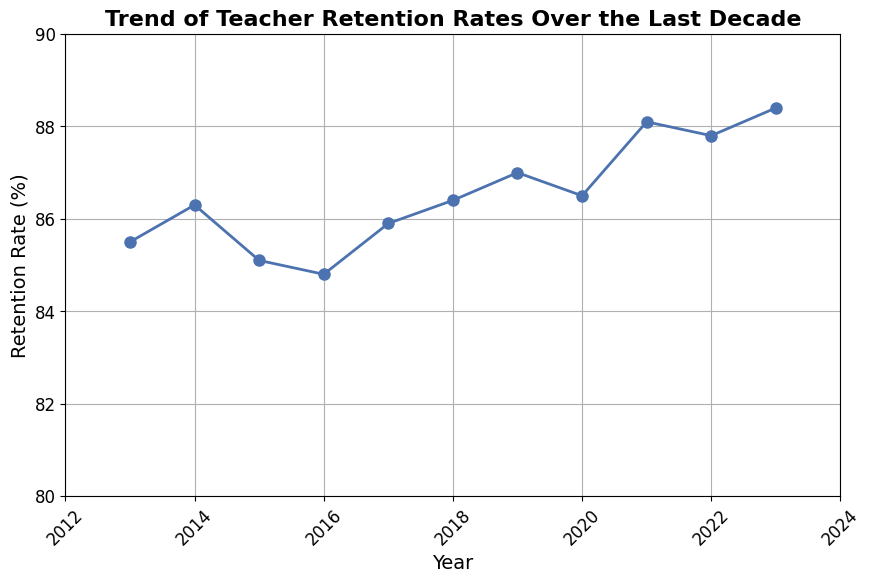what year had the highest teacher retention rate? Look at the plotted line and find the highest point. The highest point is at year 2023 with a retention rate of 88.4%.
Answer: 2023 what is the difference in retention rate between 2015 and 2023? Subtract the retention rate of 2015 from the retention rate of 2023. 88.4% - 85.1% = 3.3%.
Answer: 3.3% how many years had a teacher retention rate higher than 86%? Look at the plotted points and count the years where the retention rate is above 86%. The years are 2014, 2018, 2019, 2021, 2022, and 2023, which makes it 6 years.
Answer: 6 which year had the lowest teacher retention rate? Find the lowest point on the plot. The lowest point is at year 2016 with a retention rate of 84.8%.
Answer: 2016 how much did the teacher retention rate change from 2020 to 2021? Subtract the retention rate of 2020 from the retention rate of 2021. 88.1% - 86.5% = 1.6%.
Answer: 1.6% in which year did the teacher retention rate first exceed 86%? Find the first year on the x-axis where the retention rate crosses 86%. This happens in 2014.
Answer: 2014 what is the average teacher retention rate over the last decade? Sum all the retention rates and divide by the number of years. (85.5 + 86.3 + 85.1 + 84.8 + 85.9 + 86.4 + 87.0 + 86.5 + 88.1 + 87.8 + 88.4)/11 ≈ 86.4%.
Answer: 86.4% compare the retention rates of 2013 and 2017. Which is higher? Look at the plotted points for 2013 and 2017. 2013 has a retention rate of 85.5% and 2017 has 85.9%. Since 85.9% is higher, 2017 is higher.
Answer: 2017 what trend do you observe in the teacher retention rate from 2016 to 2023? Observe the general direction of the line from 2016 to 2023. The retention rate shows an upward trend.
Answer: upward trend 